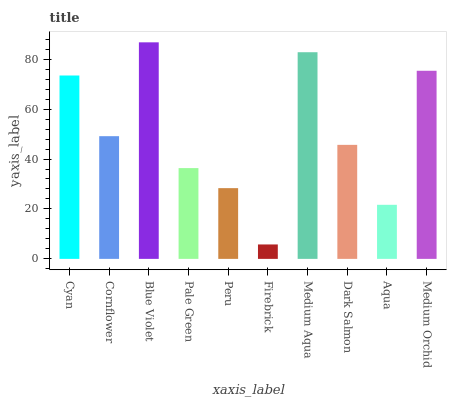Is Firebrick the minimum?
Answer yes or no. Yes. Is Blue Violet the maximum?
Answer yes or no. Yes. Is Cornflower the minimum?
Answer yes or no. No. Is Cornflower the maximum?
Answer yes or no. No. Is Cyan greater than Cornflower?
Answer yes or no. Yes. Is Cornflower less than Cyan?
Answer yes or no. Yes. Is Cornflower greater than Cyan?
Answer yes or no. No. Is Cyan less than Cornflower?
Answer yes or no. No. Is Cornflower the high median?
Answer yes or no. Yes. Is Dark Salmon the low median?
Answer yes or no. Yes. Is Pale Green the high median?
Answer yes or no. No. Is Medium Orchid the low median?
Answer yes or no. No. 